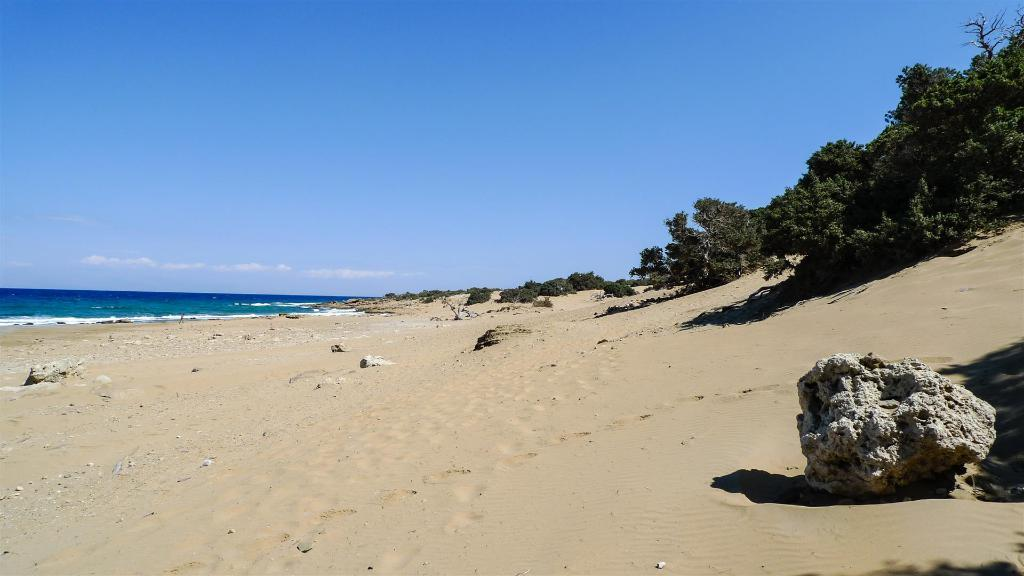What type of terrain is depicted in the image? There is sand and rocks in the image. What can be seen in the background of the image? There are trees, water, and the sky visible in the background of the image. What type of copy machine can be seen in the image? There is no copy machine present in the image; it features a natural landscape with sand, rocks, trees, water, and the sky. Can you describe the bat that is flying in the image? There is no bat present in the image; it features a natural landscape with sand, rocks, trees, water, and the sky. 